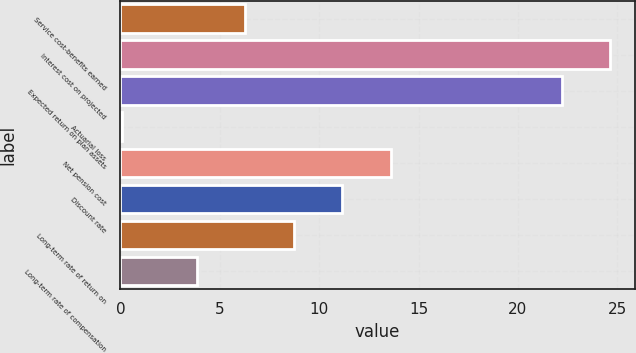Convert chart to OTSL. <chart><loc_0><loc_0><loc_500><loc_500><bar_chart><fcel>Service cost-benefits earned<fcel>Interest cost on projected<fcel>Expected return on plan assets<fcel>Actuarial loss<fcel>Net pension cost<fcel>Discount rate<fcel>Long-term rate of return on<fcel>Long-term rate of compensation<nl><fcel>6.27<fcel>24.64<fcel>22.2<fcel>0.1<fcel>13.59<fcel>11.15<fcel>8.71<fcel>3.83<nl></chart> 